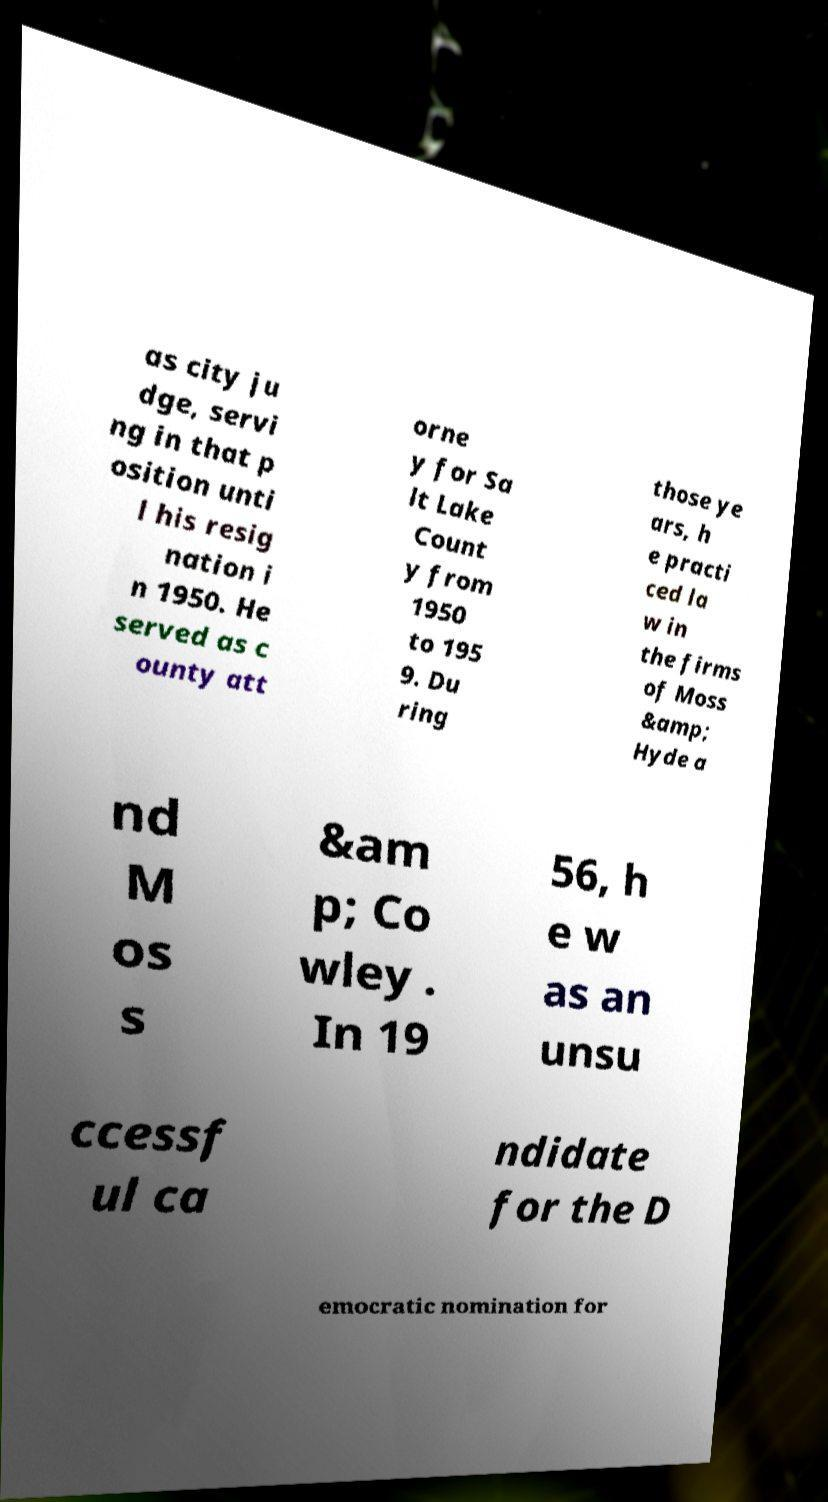Please read and relay the text visible in this image. What does it say? as city ju dge, servi ng in that p osition unti l his resig nation i n 1950. He served as c ounty att orne y for Sa lt Lake Count y from 1950 to 195 9. Du ring those ye ars, h e practi ced la w in the firms of Moss &amp; Hyde a nd M os s &am p; Co wley . In 19 56, h e w as an unsu ccessf ul ca ndidate for the D emocratic nomination for 